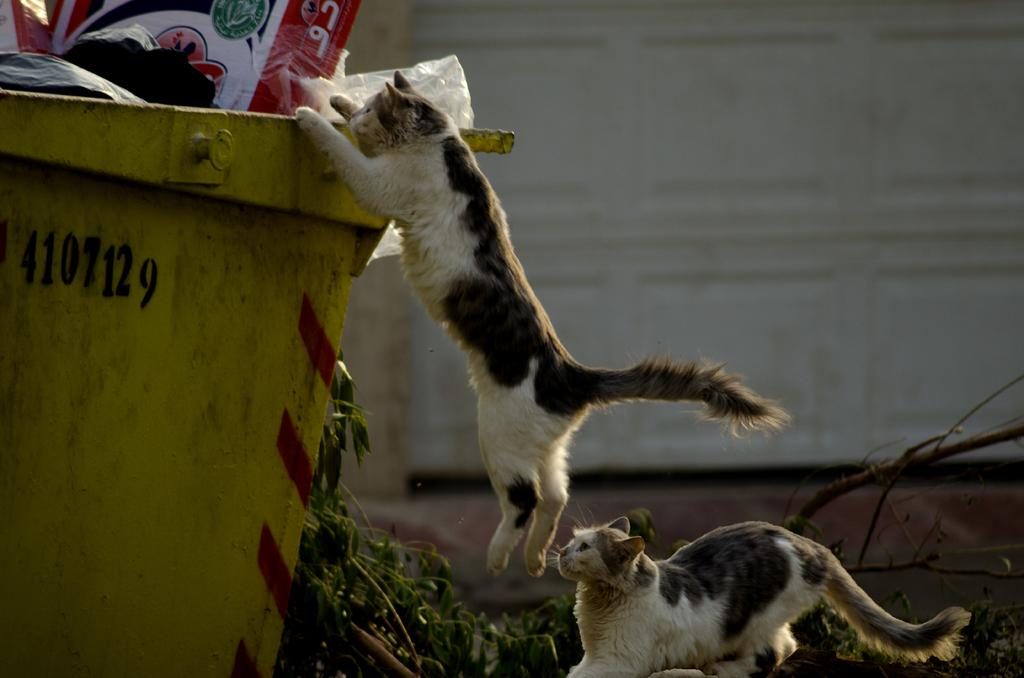How many cats are present in the image? There are two cats in the image. What is one of the cats doing in the image? One cat is jumping into a dustbin. What can be seen beside the dustbin in the image? There are leaves of a tree beside the dustbin. What is visible in the background of the image? There is a wall in the background of the image. What type of soap is the cat using to clean itself in the image? There is no soap present in the image, and the cats are not shown cleaning themselves. 